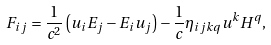Convert formula to latex. <formula><loc_0><loc_0><loc_500><loc_500>F _ { i j } = \frac { 1 } { c ^ { 2 } } \left ( u _ { i } E _ { j } - E _ { i } u _ { j } \right ) - \frac { 1 } { c } \eta _ { i j k q } u ^ { k } H ^ { q } ,</formula> 